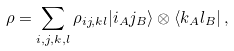<formula> <loc_0><loc_0><loc_500><loc_500>\rho = \sum _ { i , j , k , l } \rho _ { i j , k l } | i _ { A } j _ { B } \rangle \otimes \langle k _ { A } l _ { B } | \, ,</formula> 